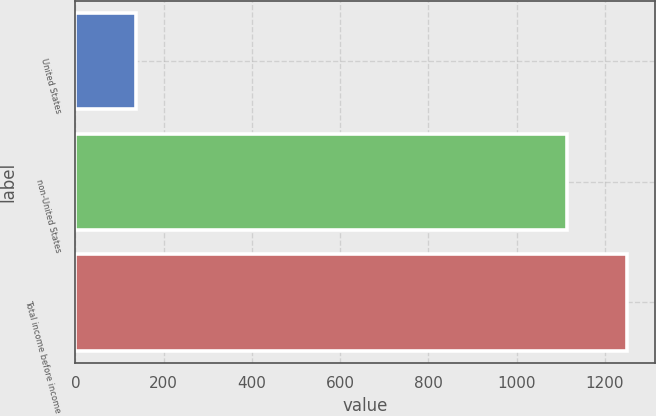Convert chart. <chart><loc_0><loc_0><loc_500><loc_500><bar_chart><fcel>United States<fcel>non-United States<fcel>Total income before income<nl><fcel>138<fcel>1113<fcel>1251<nl></chart> 